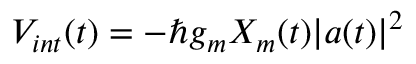<formula> <loc_0><loc_0><loc_500><loc_500>\begin{array} { r } { V _ { i n t } ( t ) = - \hbar { g } _ { m } X _ { m } ( t ) | a ( t ) | ^ { 2 } } \end{array}</formula> 